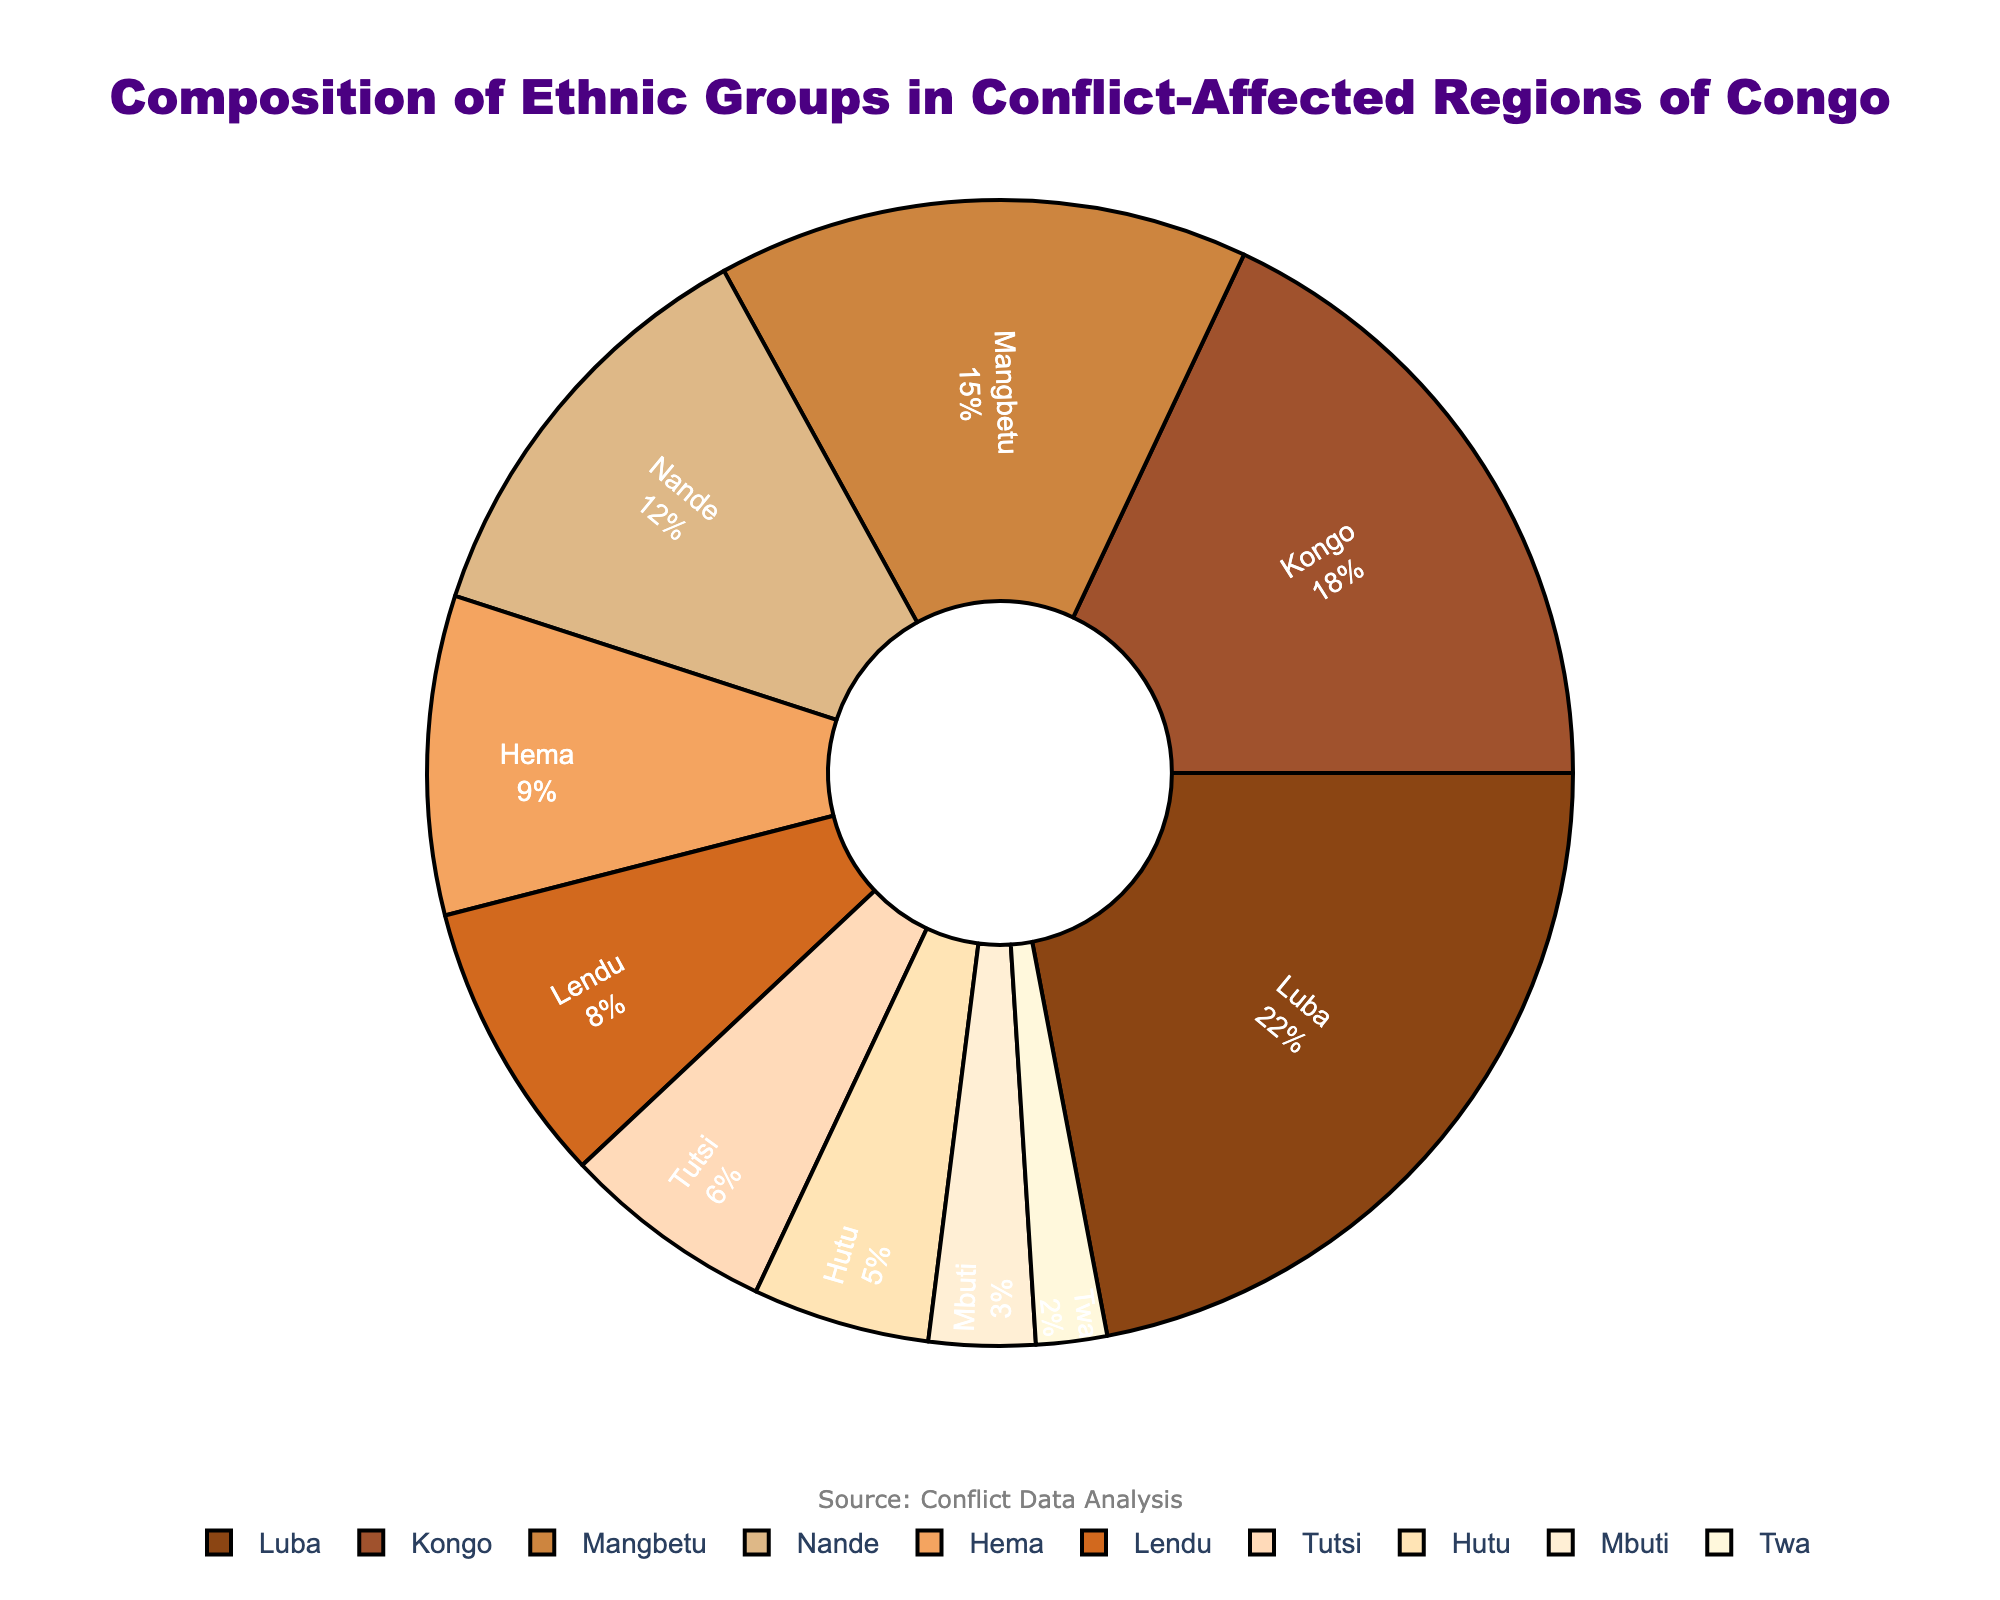What percentage of the ethnic groups are Luba and Kongo combined? To find the combined percentage, add the percentages of the Luba and Kongo ethnic groups: 22% (Luba) + 18% (Kongo) = 40%.
Answer: 40% Which ethnic group has the smallest representation in the pie chart? By inspecting the pie chart, the Twa ethnic group has the smallest segment with 2%.
Answer: Twa How does the representation of Nande compare to that of Hema? From the pie chart, Nande is 12% while Hema is 9%. Comparatively, Nande has a 3% higher representation than Hema.
Answer: Nande has 3% higher representation What is the combined percentage representation of the Hema and Lendu groups? Add the percentages of the Hema and Lendu ethnic groups: 9% (Hema) + 8% (Lendu) = 17%.
Answer: 17% Which group has a greater proportion: Mangbetu or Nande? The Mangbetu group has 15% while the Nande group has 12%. Therefore, Mangbetu has a greater proportion.
Answer: Mangbetu What percentage do the groups with single-digit percentages represent cumulatively? Add the percentages of Hema (9%), Lendu (8%), Tutsi (6%), Hutu (5%), Mbuti (3%) and Twa (2%): 9% + 8% + 6% + 5% + 3% + 2% = 33%.
Answer: 33% If you combine the percentages of the two smallest groups, what is their total representation? The two smallest groups are Twa (2%) and Mbuti (3%). Their combined representation is 2% + 3% = 5%.
Answer: 5% Which ethnic group is represented in brown segments? The pie chart shows that the Luba ethnic group, which has the largest segment (22%), is represented in a brown color.
Answer: Luba 